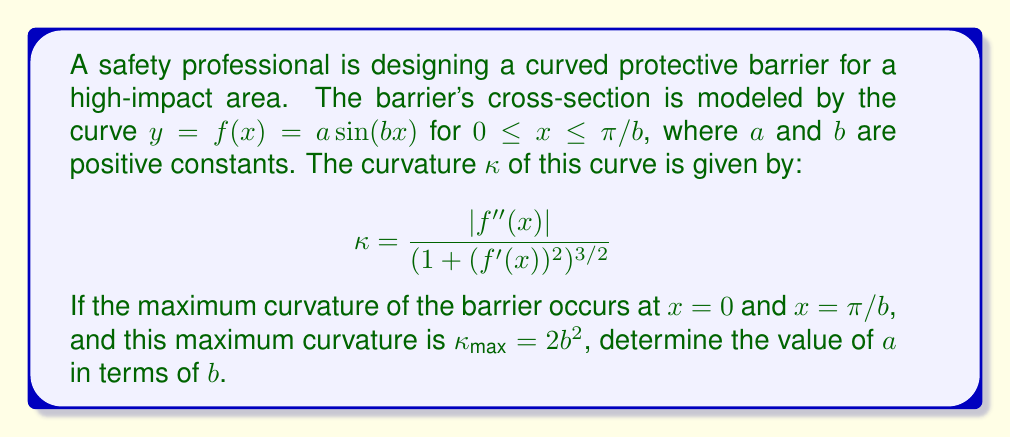Show me your answer to this math problem. To solve this problem, we'll follow these steps:

1) First, let's find $f'(x)$ and $f''(x)$:
   $f'(x) = ab \cos(bx)$
   $f''(x) = -ab^2 \sin(bx)$

2) Now, let's substitute these into the curvature formula:

   $$\kappa = \frac{|f''(x)|}{(1 + (f'(x))^2)^{3/2}} = \frac{|ab^2 \sin(bx)|}{(1 + (ab \cos(bx))^2)^{3/2}}$$

3) We're told that the maximum curvature occurs at $x = 0$ and $x = \pi/b$. Let's consider $x = 0$:

   At $x = 0$, $\sin(bx) = 0$ and $\cos(bx) = 1$, so:

   $$\kappa_{max} = \frac{0}{(1 + (ab)^2)^{3/2}} = 0$$

   This doesn't match our given $\kappa_{max} = 2b^2$, so let's consider $x = \pi/b$:

   At $x = \pi/b$, $\sin(bx) = 0$ and $\cos(bx) = -1$, which gives the same result as $x = 0$.

4) This means our initial assumption about where the maximum curvature occurs was incorrect. Let's find where the curvature is actually maximized:

   The curvature will be maximum when $|\sin(bx)| = 1$ and $|\cos(bx)| = 0$, which occurs at $x = \pi/(2b)$.

5) Let's calculate the curvature at this point:

   $$\kappa_{max} = \frac{ab^2}{(1 + 0)^{3/2}} = ab^2$$

6) We're given that $\kappa_{max} = 2b^2$, so:

   $$ab^2 = 2b^2$$

7) Solving for $a$:

   $$a = 2$$
Answer: $a = 2$ 